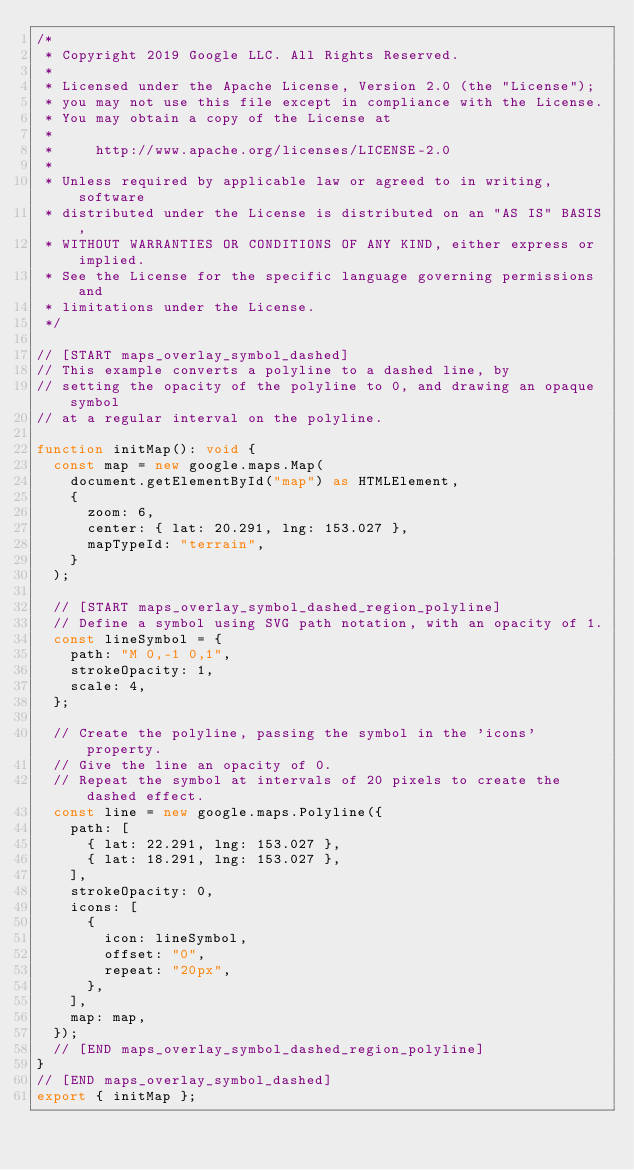Convert code to text. <code><loc_0><loc_0><loc_500><loc_500><_TypeScript_>/*
 * Copyright 2019 Google LLC. All Rights Reserved.
 *
 * Licensed under the Apache License, Version 2.0 (the "License");
 * you may not use this file except in compliance with the License.
 * You may obtain a copy of the License at
 *
 *     http://www.apache.org/licenses/LICENSE-2.0
 *
 * Unless required by applicable law or agreed to in writing, software
 * distributed under the License is distributed on an "AS IS" BASIS,
 * WITHOUT WARRANTIES OR CONDITIONS OF ANY KIND, either express or implied.
 * See the License for the specific language governing permissions and
 * limitations under the License.
 */

// [START maps_overlay_symbol_dashed]
// This example converts a polyline to a dashed line, by
// setting the opacity of the polyline to 0, and drawing an opaque symbol
// at a regular interval on the polyline.

function initMap(): void {
  const map = new google.maps.Map(
    document.getElementById("map") as HTMLElement,
    {
      zoom: 6,
      center: { lat: 20.291, lng: 153.027 },
      mapTypeId: "terrain",
    }
  );

  // [START maps_overlay_symbol_dashed_region_polyline]
  // Define a symbol using SVG path notation, with an opacity of 1.
  const lineSymbol = {
    path: "M 0,-1 0,1",
    strokeOpacity: 1,
    scale: 4,
  };

  // Create the polyline, passing the symbol in the 'icons' property.
  // Give the line an opacity of 0.
  // Repeat the symbol at intervals of 20 pixels to create the dashed effect.
  const line = new google.maps.Polyline({
    path: [
      { lat: 22.291, lng: 153.027 },
      { lat: 18.291, lng: 153.027 },
    ],
    strokeOpacity: 0,
    icons: [
      {
        icon: lineSymbol,
        offset: "0",
        repeat: "20px",
      },
    ],
    map: map,
  });
  // [END maps_overlay_symbol_dashed_region_polyline]
}
// [END maps_overlay_symbol_dashed]
export { initMap };
</code> 